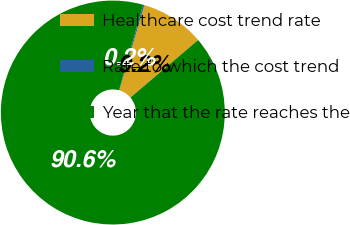Convert chart. <chart><loc_0><loc_0><loc_500><loc_500><pie_chart><fcel>Healthcare cost trend rate<fcel>Rate to which the cost trend<fcel>Year that the rate reaches the<nl><fcel>9.24%<fcel>0.2%<fcel>90.56%<nl></chart> 